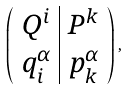<formula> <loc_0><loc_0><loc_500><loc_500>\left ( \begin{array} { c | c } Q ^ { i } & P ^ { k } \\ q _ { i } ^ { \alpha } & p _ { k } ^ { \alpha } \end{array} \right ) ,</formula> 